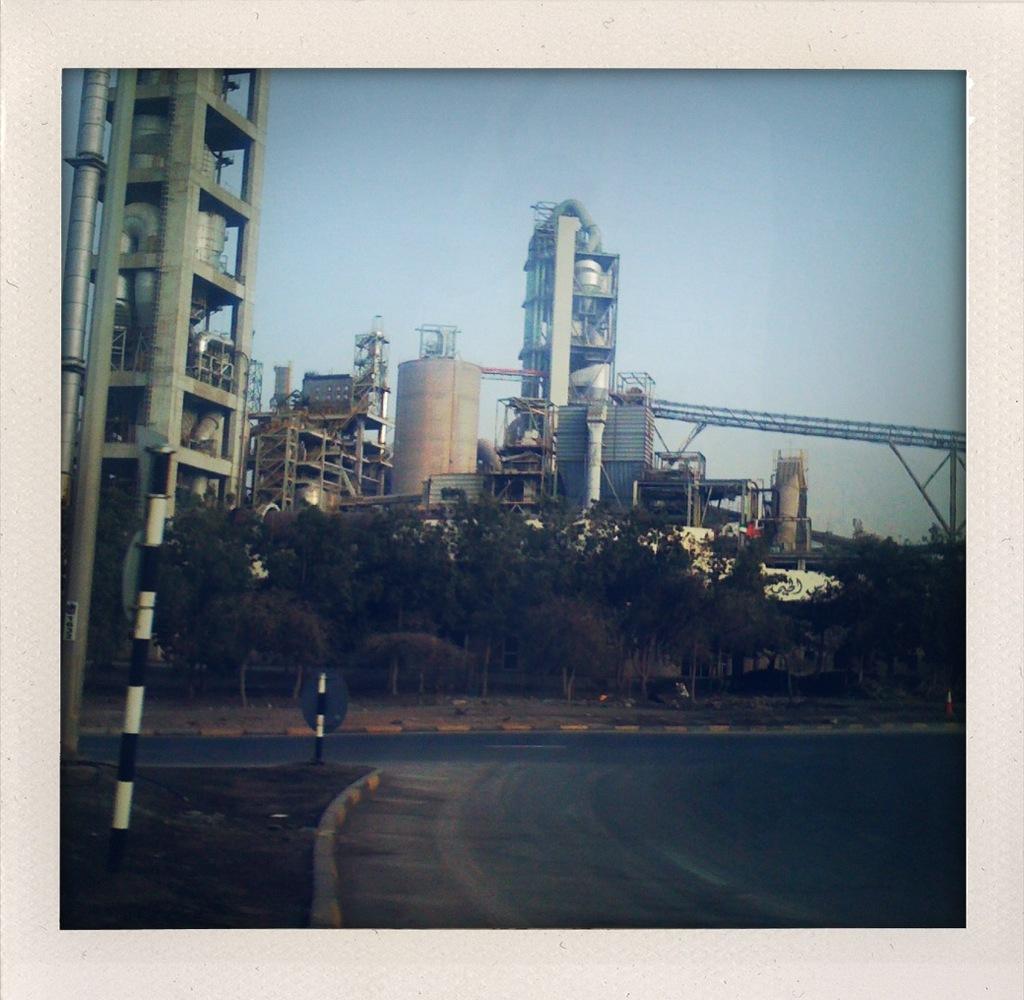Can you describe this image briefly? In this image I can see trees in green color. I can also see few poles in white and black color, background I can see buildings in white color and sky in blue color. 